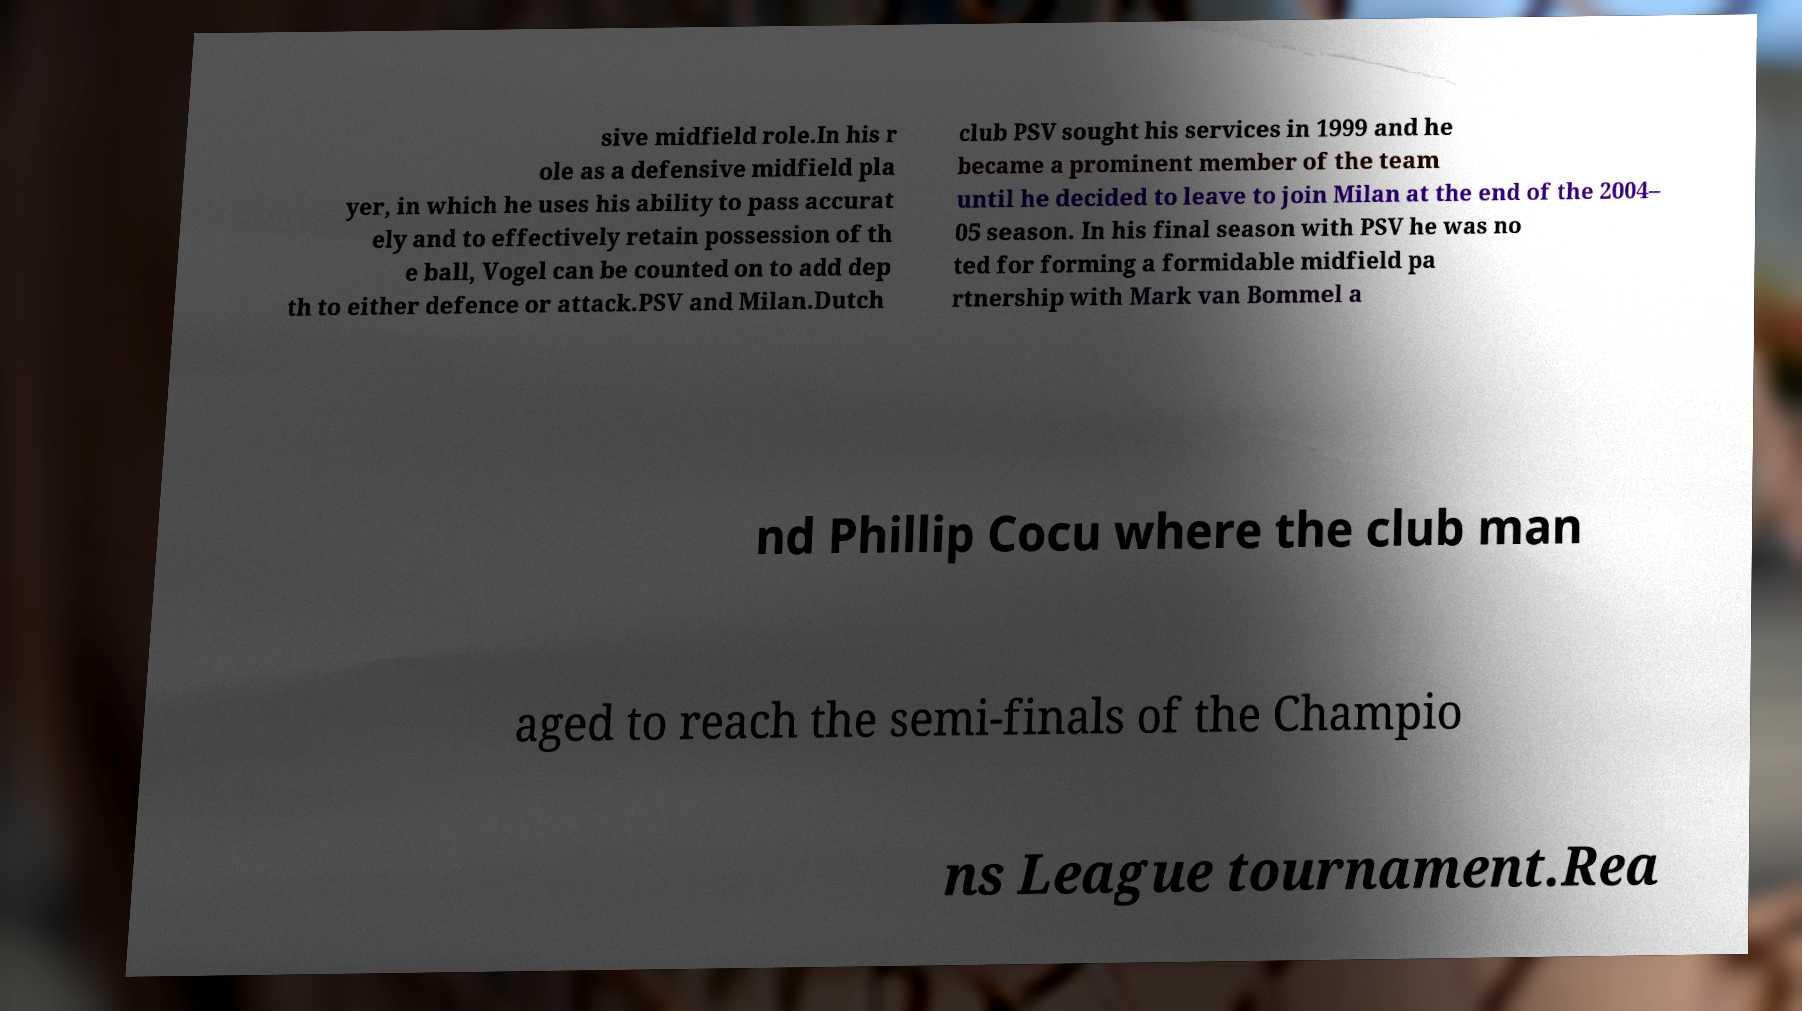What messages or text are displayed in this image? I need them in a readable, typed format. sive midfield role.In his r ole as a defensive midfield pla yer, in which he uses his ability to pass accurat ely and to effectively retain possession of th e ball, Vogel can be counted on to add dep th to either defence or attack.PSV and Milan.Dutch club PSV sought his services in 1999 and he became a prominent member of the team until he decided to leave to join Milan at the end of the 2004– 05 season. In his final season with PSV he was no ted for forming a formidable midfield pa rtnership with Mark van Bommel a nd Phillip Cocu where the club man aged to reach the semi-finals of the Champio ns League tournament.Rea 